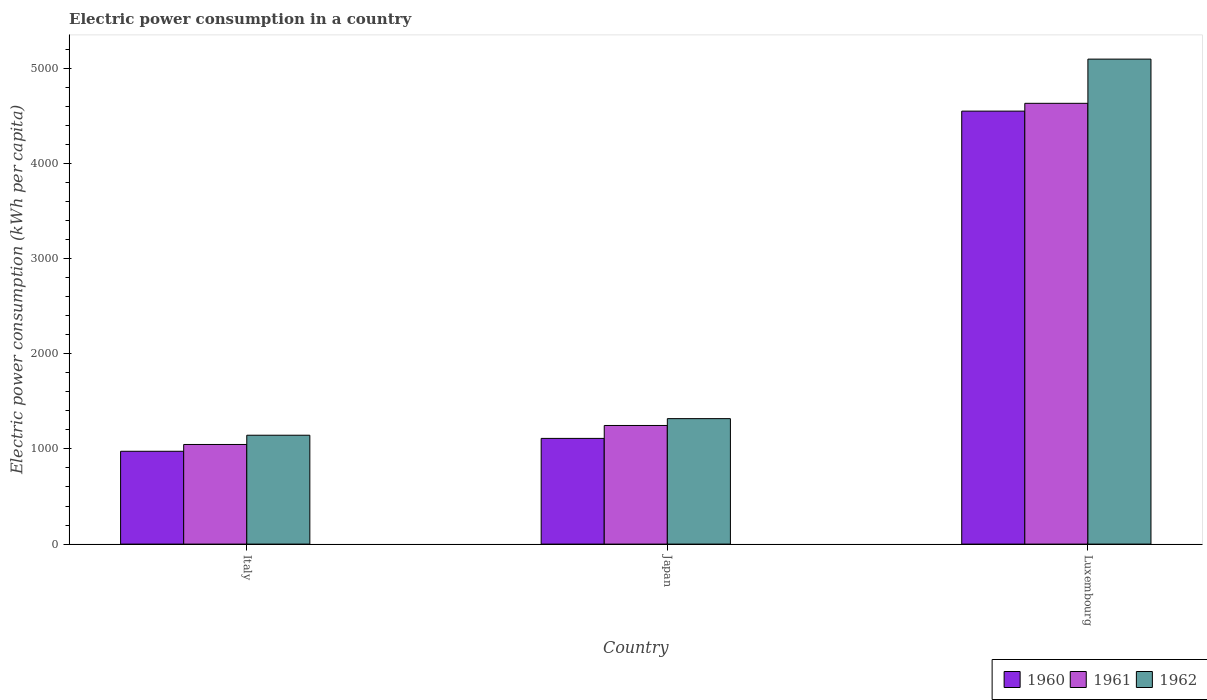How many groups of bars are there?
Keep it short and to the point. 3. How many bars are there on the 3rd tick from the right?
Your response must be concise. 3. What is the label of the 3rd group of bars from the left?
Give a very brief answer. Luxembourg. What is the electric power consumption in in 1962 in Italy?
Give a very brief answer. 1143.61. Across all countries, what is the maximum electric power consumption in in 1961?
Make the answer very short. 4630.02. Across all countries, what is the minimum electric power consumption in in 1960?
Your answer should be very brief. 975.03. In which country was the electric power consumption in in 1962 maximum?
Ensure brevity in your answer.  Luxembourg. What is the total electric power consumption in in 1960 in the graph?
Make the answer very short. 6633.49. What is the difference between the electric power consumption in in 1960 in Italy and that in Japan?
Your response must be concise. -135.24. What is the difference between the electric power consumption in in 1961 in Luxembourg and the electric power consumption in in 1960 in Japan?
Your answer should be very brief. 3519.76. What is the average electric power consumption in in 1961 per country?
Provide a short and direct response. 2307.48. What is the difference between the electric power consumption in of/in 1961 and electric power consumption in of/in 1962 in Italy?
Your answer should be compact. -97.19. In how many countries, is the electric power consumption in in 1960 greater than 4000 kWh per capita?
Offer a terse response. 1. What is the ratio of the electric power consumption in in 1961 in Japan to that in Luxembourg?
Provide a short and direct response. 0.27. Is the electric power consumption in in 1962 in Japan less than that in Luxembourg?
Your answer should be compact. Yes. What is the difference between the highest and the second highest electric power consumption in in 1961?
Your answer should be very brief. -3384.01. What is the difference between the highest and the lowest electric power consumption in in 1961?
Offer a very short reply. 3583.61. In how many countries, is the electric power consumption in in 1960 greater than the average electric power consumption in in 1960 taken over all countries?
Your answer should be very brief. 1. What does the 2nd bar from the left in Japan represents?
Your response must be concise. 1961. What does the 3rd bar from the right in Japan represents?
Keep it short and to the point. 1960. Is it the case that in every country, the sum of the electric power consumption in in 1961 and electric power consumption in in 1962 is greater than the electric power consumption in in 1960?
Give a very brief answer. Yes. How many bars are there?
Your answer should be very brief. 9. Are all the bars in the graph horizontal?
Provide a short and direct response. No. How many countries are there in the graph?
Provide a short and direct response. 3. Does the graph contain any zero values?
Your answer should be very brief. No. How many legend labels are there?
Provide a succinct answer. 3. How are the legend labels stacked?
Your answer should be very brief. Horizontal. What is the title of the graph?
Give a very brief answer. Electric power consumption in a country. What is the label or title of the X-axis?
Offer a terse response. Country. What is the label or title of the Y-axis?
Make the answer very short. Electric power consumption (kWh per capita). What is the Electric power consumption (kWh per capita) in 1960 in Italy?
Ensure brevity in your answer.  975.03. What is the Electric power consumption (kWh per capita) of 1961 in Italy?
Your answer should be very brief. 1046.42. What is the Electric power consumption (kWh per capita) of 1962 in Italy?
Provide a short and direct response. 1143.61. What is the Electric power consumption (kWh per capita) of 1960 in Japan?
Give a very brief answer. 1110.26. What is the Electric power consumption (kWh per capita) of 1961 in Japan?
Provide a short and direct response. 1246.01. What is the Electric power consumption (kWh per capita) of 1962 in Japan?
Ensure brevity in your answer.  1317.93. What is the Electric power consumption (kWh per capita) in 1960 in Luxembourg?
Your answer should be very brief. 4548.21. What is the Electric power consumption (kWh per capita) of 1961 in Luxembourg?
Make the answer very short. 4630.02. What is the Electric power consumption (kWh per capita) in 1962 in Luxembourg?
Provide a short and direct response. 5094.31. Across all countries, what is the maximum Electric power consumption (kWh per capita) in 1960?
Make the answer very short. 4548.21. Across all countries, what is the maximum Electric power consumption (kWh per capita) of 1961?
Provide a succinct answer. 4630.02. Across all countries, what is the maximum Electric power consumption (kWh per capita) of 1962?
Keep it short and to the point. 5094.31. Across all countries, what is the minimum Electric power consumption (kWh per capita) in 1960?
Provide a succinct answer. 975.03. Across all countries, what is the minimum Electric power consumption (kWh per capita) in 1961?
Offer a terse response. 1046.42. Across all countries, what is the minimum Electric power consumption (kWh per capita) in 1962?
Ensure brevity in your answer.  1143.61. What is the total Electric power consumption (kWh per capita) in 1960 in the graph?
Offer a very short reply. 6633.49. What is the total Electric power consumption (kWh per capita) in 1961 in the graph?
Keep it short and to the point. 6922.45. What is the total Electric power consumption (kWh per capita) of 1962 in the graph?
Offer a terse response. 7555.85. What is the difference between the Electric power consumption (kWh per capita) of 1960 in Italy and that in Japan?
Offer a very short reply. -135.24. What is the difference between the Electric power consumption (kWh per capita) of 1961 in Italy and that in Japan?
Ensure brevity in your answer.  -199.6. What is the difference between the Electric power consumption (kWh per capita) of 1962 in Italy and that in Japan?
Provide a succinct answer. -174.33. What is the difference between the Electric power consumption (kWh per capita) in 1960 in Italy and that in Luxembourg?
Your answer should be very brief. -3573.18. What is the difference between the Electric power consumption (kWh per capita) of 1961 in Italy and that in Luxembourg?
Offer a very short reply. -3583.61. What is the difference between the Electric power consumption (kWh per capita) of 1962 in Italy and that in Luxembourg?
Your answer should be compact. -3950.71. What is the difference between the Electric power consumption (kWh per capita) of 1960 in Japan and that in Luxembourg?
Provide a short and direct response. -3437.94. What is the difference between the Electric power consumption (kWh per capita) in 1961 in Japan and that in Luxembourg?
Provide a short and direct response. -3384.01. What is the difference between the Electric power consumption (kWh per capita) in 1962 in Japan and that in Luxembourg?
Provide a short and direct response. -3776.38. What is the difference between the Electric power consumption (kWh per capita) of 1960 in Italy and the Electric power consumption (kWh per capita) of 1961 in Japan?
Your answer should be compact. -270.99. What is the difference between the Electric power consumption (kWh per capita) of 1960 in Italy and the Electric power consumption (kWh per capita) of 1962 in Japan?
Make the answer very short. -342.91. What is the difference between the Electric power consumption (kWh per capita) of 1961 in Italy and the Electric power consumption (kWh per capita) of 1962 in Japan?
Your answer should be very brief. -271.52. What is the difference between the Electric power consumption (kWh per capita) in 1960 in Italy and the Electric power consumption (kWh per capita) in 1961 in Luxembourg?
Keep it short and to the point. -3655. What is the difference between the Electric power consumption (kWh per capita) in 1960 in Italy and the Electric power consumption (kWh per capita) in 1962 in Luxembourg?
Make the answer very short. -4119.28. What is the difference between the Electric power consumption (kWh per capita) in 1961 in Italy and the Electric power consumption (kWh per capita) in 1962 in Luxembourg?
Make the answer very short. -4047.9. What is the difference between the Electric power consumption (kWh per capita) of 1960 in Japan and the Electric power consumption (kWh per capita) of 1961 in Luxembourg?
Provide a succinct answer. -3519.76. What is the difference between the Electric power consumption (kWh per capita) of 1960 in Japan and the Electric power consumption (kWh per capita) of 1962 in Luxembourg?
Keep it short and to the point. -3984.05. What is the difference between the Electric power consumption (kWh per capita) in 1961 in Japan and the Electric power consumption (kWh per capita) in 1962 in Luxembourg?
Make the answer very short. -3848.3. What is the average Electric power consumption (kWh per capita) in 1960 per country?
Make the answer very short. 2211.16. What is the average Electric power consumption (kWh per capita) in 1961 per country?
Make the answer very short. 2307.48. What is the average Electric power consumption (kWh per capita) in 1962 per country?
Ensure brevity in your answer.  2518.62. What is the difference between the Electric power consumption (kWh per capita) in 1960 and Electric power consumption (kWh per capita) in 1961 in Italy?
Provide a succinct answer. -71.39. What is the difference between the Electric power consumption (kWh per capita) of 1960 and Electric power consumption (kWh per capita) of 1962 in Italy?
Make the answer very short. -168.58. What is the difference between the Electric power consumption (kWh per capita) in 1961 and Electric power consumption (kWh per capita) in 1962 in Italy?
Ensure brevity in your answer.  -97.19. What is the difference between the Electric power consumption (kWh per capita) in 1960 and Electric power consumption (kWh per capita) in 1961 in Japan?
Provide a short and direct response. -135.75. What is the difference between the Electric power consumption (kWh per capita) in 1960 and Electric power consumption (kWh per capita) in 1962 in Japan?
Offer a very short reply. -207.67. What is the difference between the Electric power consumption (kWh per capita) of 1961 and Electric power consumption (kWh per capita) of 1962 in Japan?
Keep it short and to the point. -71.92. What is the difference between the Electric power consumption (kWh per capita) of 1960 and Electric power consumption (kWh per capita) of 1961 in Luxembourg?
Make the answer very short. -81.82. What is the difference between the Electric power consumption (kWh per capita) of 1960 and Electric power consumption (kWh per capita) of 1962 in Luxembourg?
Your answer should be very brief. -546.11. What is the difference between the Electric power consumption (kWh per capita) of 1961 and Electric power consumption (kWh per capita) of 1962 in Luxembourg?
Ensure brevity in your answer.  -464.29. What is the ratio of the Electric power consumption (kWh per capita) in 1960 in Italy to that in Japan?
Provide a short and direct response. 0.88. What is the ratio of the Electric power consumption (kWh per capita) in 1961 in Italy to that in Japan?
Keep it short and to the point. 0.84. What is the ratio of the Electric power consumption (kWh per capita) of 1962 in Italy to that in Japan?
Keep it short and to the point. 0.87. What is the ratio of the Electric power consumption (kWh per capita) in 1960 in Italy to that in Luxembourg?
Offer a terse response. 0.21. What is the ratio of the Electric power consumption (kWh per capita) of 1961 in Italy to that in Luxembourg?
Ensure brevity in your answer.  0.23. What is the ratio of the Electric power consumption (kWh per capita) of 1962 in Italy to that in Luxembourg?
Make the answer very short. 0.22. What is the ratio of the Electric power consumption (kWh per capita) in 1960 in Japan to that in Luxembourg?
Give a very brief answer. 0.24. What is the ratio of the Electric power consumption (kWh per capita) of 1961 in Japan to that in Luxembourg?
Ensure brevity in your answer.  0.27. What is the ratio of the Electric power consumption (kWh per capita) of 1962 in Japan to that in Luxembourg?
Your answer should be very brief. 0.26. What is the difference between the highest and the second highest Electric power consumption (kWh per capita) in 1960?
Ensure brevity in your answer.  3437.94. What is the difference between the highest and the second highest Electric power consumption (kWh per capita) in 1961?
Offer a very short reply. 3384.01. What is the difference between the highest and the second highest Electric power consumption (kWh per capita) of 1962?
Your answer should be compact. 3776.38. What is the difference between the highest and the lowest Electric power consumption (kWh per capita) of 1960?
Your answer should be very brief. 3573.18. What is the difference between the highest and the lowest Electric power consumption (kWh per capita) in 1961?
Give a very brief answer. 3583.61. What is the difference between the highest and the lowest Electric power consumption (kWh per capita) of 1962?
Offer a very short reply. 3950.71. 